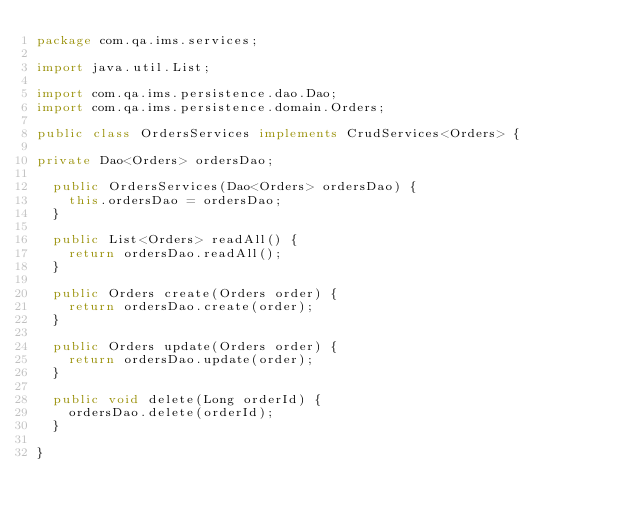Convert code to text. <code><loc_0><loc_0><loc_500><loc_500><_Java_>package com.qa.ims.services;

import java.util.List;

import com.qa.ims.persistence.dao.Dao;
import com.qa.ims.persistence.domain.Orders;

public class OrdersServices implements CrudServices<Orders> {
	
private Dao<Orders> ordersDao;
	
	public OrdersServices(Dao<Orders> ordersDao) {
		this.ordersDao = ordersDao;
	}

	public List<Orders> readAll() {
		return ordersDao.readAll();
	}

	public Orders create(Orders order) {
		return ordersDao.create(order);
	}

	public Orders update(Orders order) {
		return ordersDao.update(order);
	}

	public void delete(Long orderId) {
		ordersDao.delete(orderId);
	}

}
</code> 